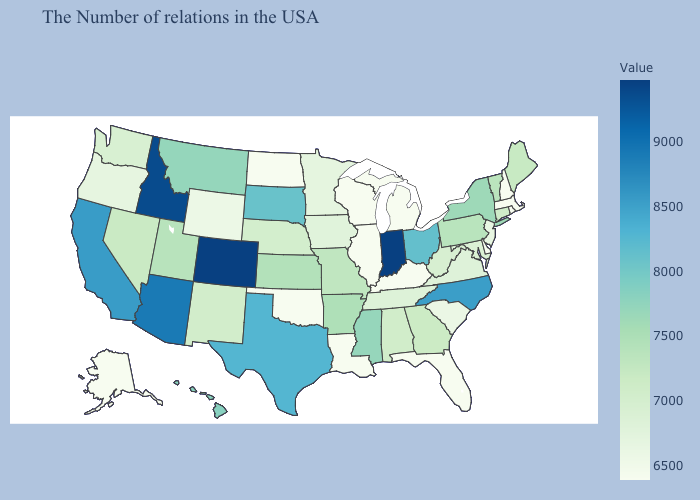Does New York have the highest value in the Northeast?
Give a very brief answer. Yes. Among the states that border Maryland , does Pennsylvania have the highest value?
Answer briefly. Yes. Does Virginia have a higher value than North Dakota?
Write a very short answer. Yes. Which states have the highest value in the USA?
Keep it brief. Colorado. Does Arkansas have a lower value than New Hampshire?
Quick response, please. No. 